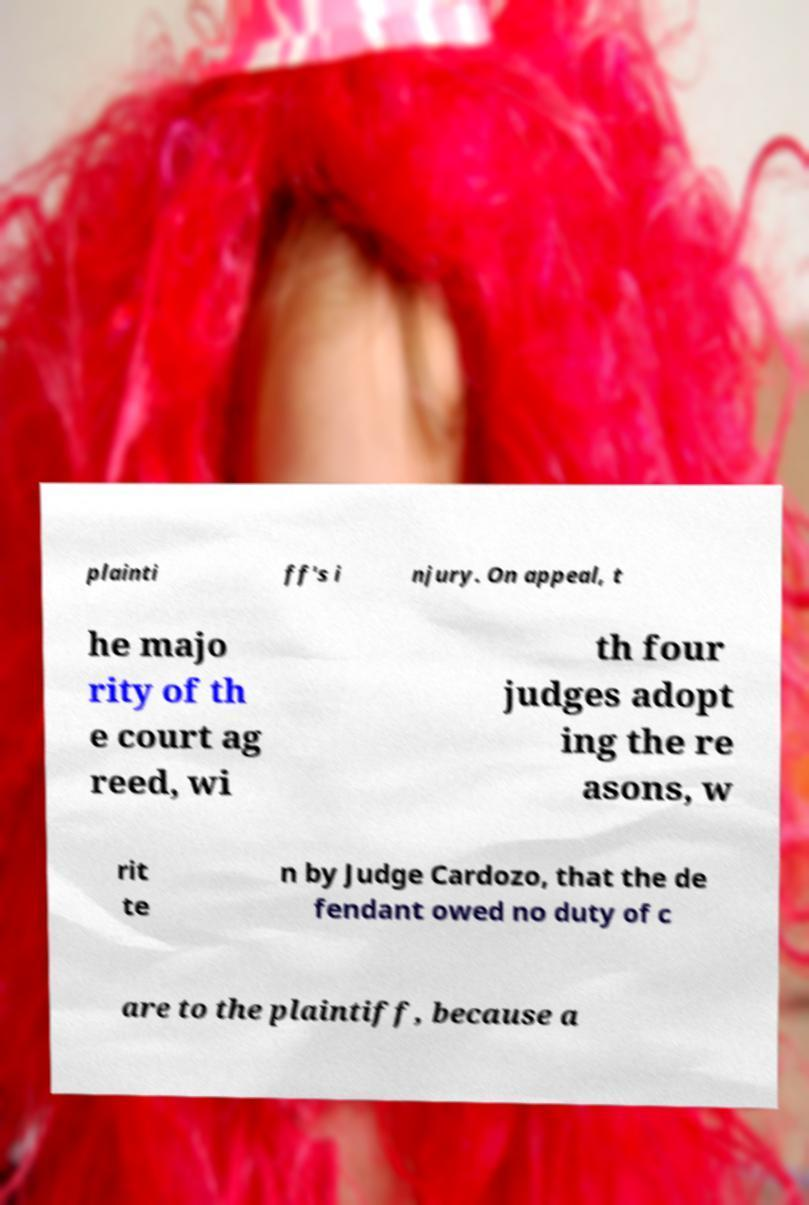Please identify and transcribe the text found in this image. plainti ff's i njury. On appeal, t he majo rity of th e court ag reed, wi th four judges adopt ing the re asons, w rit te n by Judge Cardozo, that the de fendant owed no duty of c are to the plaintiff, because a 